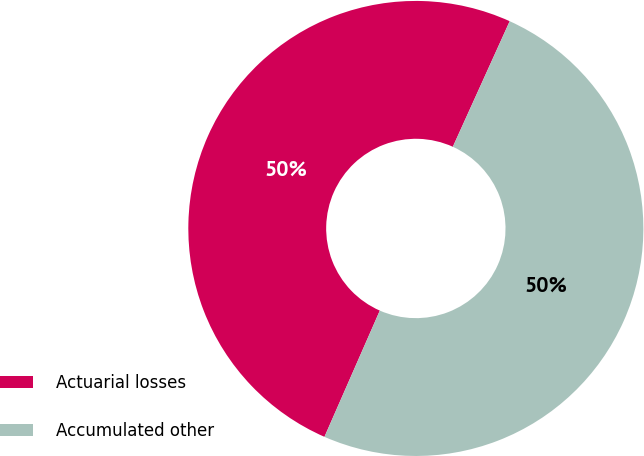Convert chart to OTSL. <chart><loc_0><loc_0><loc_500><loc_500><pie_chart><fcel>Actuarial losses<fcel>Accumulated other<nl><fcel>50.19%<fcel>49.81%<nl></chart> 